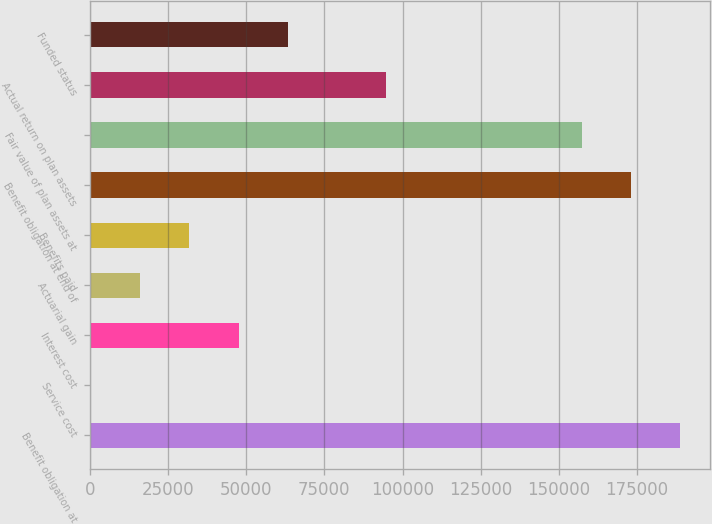<chart> <loc_0><loc_0><loc_500><loc_500><bar_chart><fcel>Benefit obligation at<fcel>Service cost<fcel>Interest cost<fcel>Actuarial gain<fcel>Benefits paid<fcel>Benefit obligation at end of<fcel>Fair value of plan assets at<fcel>Actual return on plan assets<fcel>Funded status<nl><fcel>188785<fcel>499<fcel>47570.5<fcel>16189.5<fcel>31880<fcel>173094<fcel>157404<fcel>94642<fcel>63261<nl></chart> 